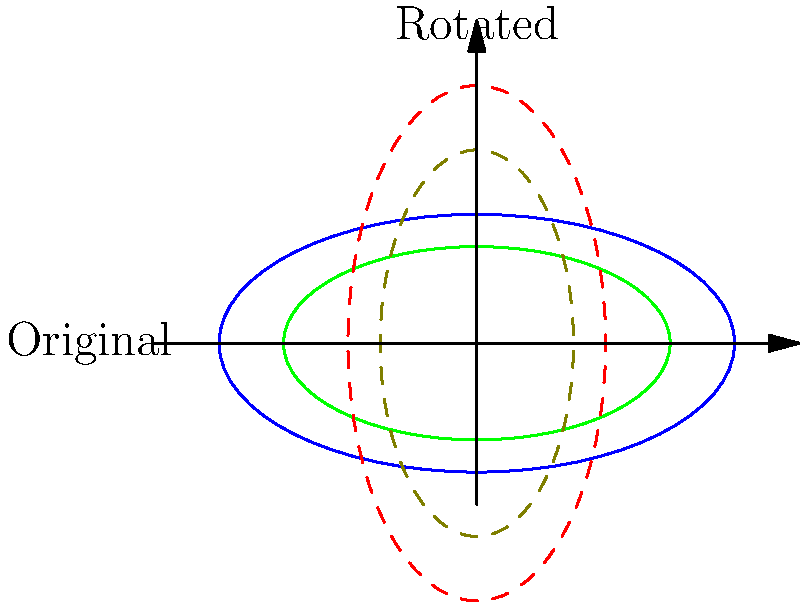The West Coast Eagles are considering a radical redesign of Optus Stadium. The current seating arrangement is represented by the blue ellipse, with the playing field shown in green. If the entire stadium layout is rotated 90 degrees clockwise, what will be the new dimensions of the seating area? Express your answer as (width, height) in meters, assuming the current dimensions are 160m wide and 80m high. To solve this problem, we need to understand the effects of a 90-degree rotation on the dimensions of an ellipse. Here's a step-by-step explanation:

1. Current dimensions of the stadium:
   Width = 160m
   Height = 80m

2. In a 90-degree clockwise rotation, the width becomes the new height, and the height becomes the new width.

3. After rotation:
   New width = Original height = 80m
   New height = Original width = 160m

4. The rotation doesn't change the shape or size of the ellipse, only its orientation.

5. Therefore, the new dimensions of the seating area after rotation will be 80m wide and 160m high.

As a die-hard West Coast Eagles fan, you might visualize this as if the entire stadium was picked up and turned on its side, with the longer axis now running vertically instead of horizontally.
Answer: (80m, 160m) 